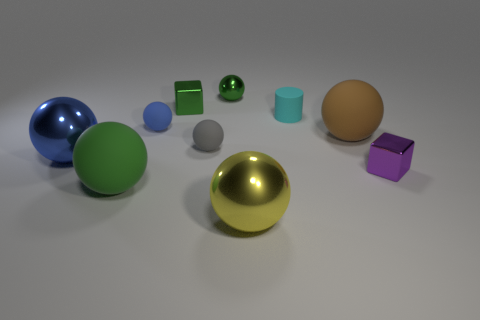Subtract all small gray rubber spheres. How many spheres are left? 6 Subtract all blue balls. How many balls are left? 5 Subtract 1 cylinders. How many cylinders are left? 0 Subtract all gray cubes. How many blue balls are left? 2 Subtract all balls. How many objects are left? 3 Add 7 small gray matte objects. How many small gray matte objects exist? 8 Subtract 0 brown blocks. How many objects are left? 10 Subtract all gray cubes. Subtract all green balls. How many cubes are left? 2 Subtract all big yellow things. Subtract all small yellow metallic spheres. How many objects are left? 9 Add 3 gray things. How many gray things are left? 4 